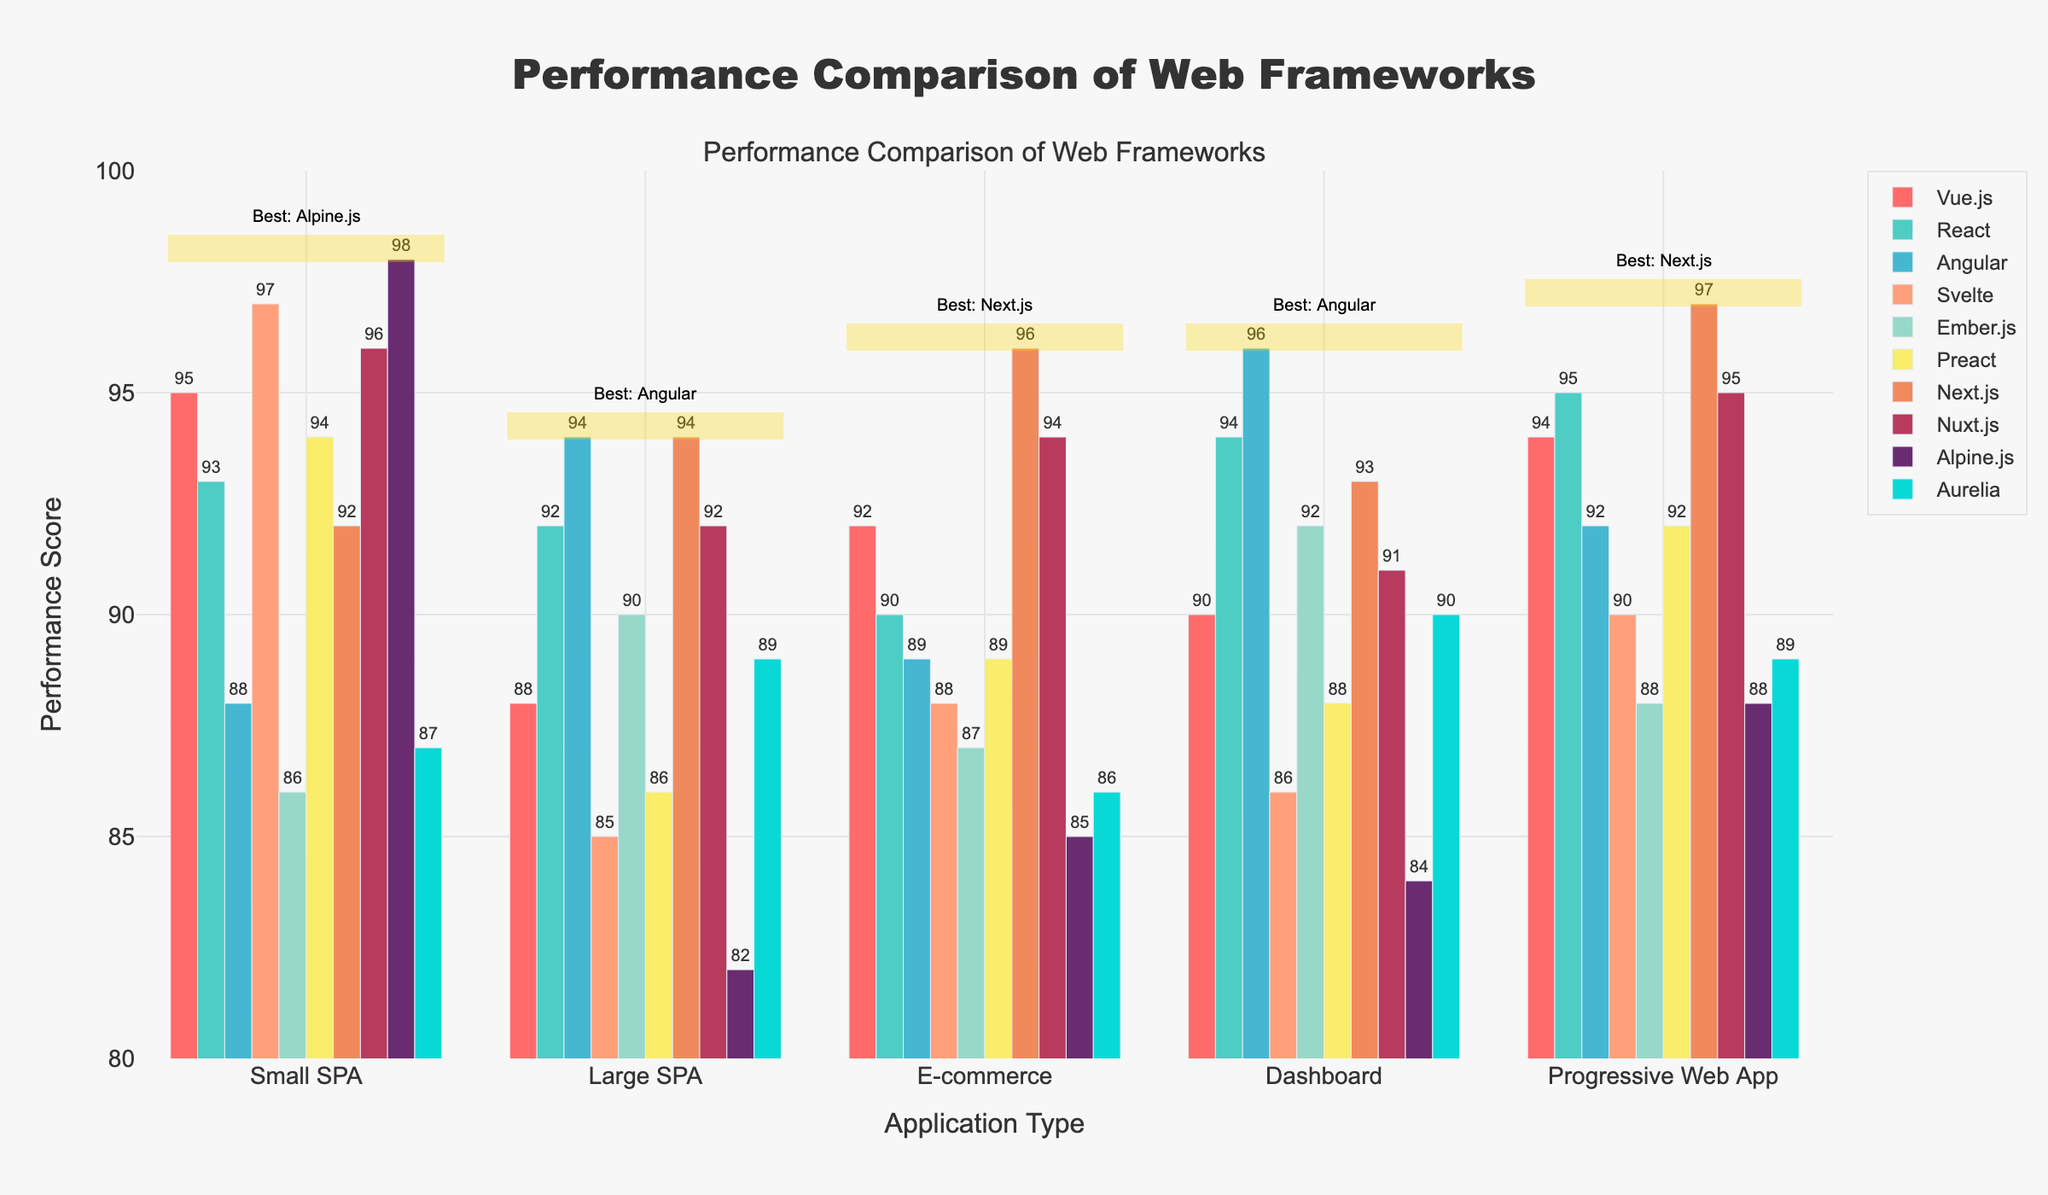Which framework has the highest performance score for Small SPA? Look at the bars in the "Small SPA" category and identify the highest one. The framework with the highest score is Alpine.js with a score of 98.
Answer: Alpine.js What is the average performance score of Angular across all application types? Sum up all the performance scores of Angular (88 + 94 + 89 + 96 + 92) which equals 459, then divide by the number of categories (5), to get the average score (459/5 = 91.8).
Answer: 91.8 Which two frameworks have the closest performance scores for E-commerce? Compare the bars in the "E-commerce" category to determine the two frameworks with scores close to each other. Vue.js and Nuxt.js have the closest scores of 92 and 94, respectively.
Answer: Vue.js and Nuxt.js Is React's performance better in Large SPA or E-commerce? Compare React's performance scores for Large SPA (92) and E-commerce (90). React's score in Large SPA is higher.
Answer: Large SPA What is the difference in performance scores between Vue.js and Svelte for Progressive Web App? Subtract Svelte's score from Vue.js's score for Progressive Web App (94 - 90 = 4).
Answer: 4 Which framework shows the best performance in Dashboards? Identify the highest bar in the "Dashboard" category. Angular has the highest score of 96.
Answer: Angular What is the combined performance score for Preact and Aurelia in Small SPA? Add the performance scores of Preact and Aurelia in Small SPA (94 + 87 = 181).
Answer: 181 Which framework has the lowest performance score for Large SPA? Look at the bars in the "Large SPA" category and find the lowest one. Alpine.js has the lowest score of 82.
Answer: Alpine.js How many frameworks have performance scores of 90 or above in E-commerce? Count the number of bars in the "E-commerce" category with scores of 90 or higher. There are four frameworks: React, Vue.js, Nuxt.js, and Next.js.
Answer: 4 Which framework performs better in Dashboards, Ember.js or Aurelia? Compare Ember.js's and Aurelia's scores in the "Dashboard" category (92 and 90 respectively). Ember.js has a better score.
Answer: Ember.js 